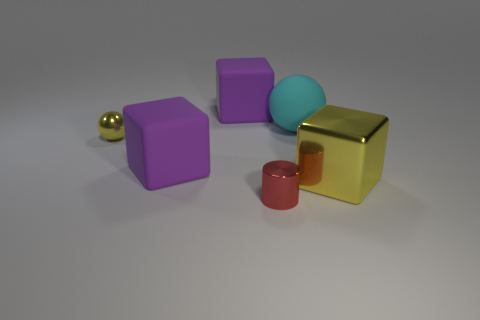How many other objects are there of the same material as the cylinder?
Your answer should be very brief. 2. Are there any big rubber blocks on the right side of the large purple rubber cube on the left side of the big matte block behind the tiny metallic ball?
Provide a succinct answer. Yes. The other small thing that is the same shape as the cyan thing is what color?
Offer a terse response. Yellow. What number of green things are metallic things or spheres?
Your response must be concise. 0. The small thing that is to the left of the rubber cube behind the cyan ball is made of what material?
Provide a short and direct response. Metal. Is the shape of the big cyan object the same as the small yellow thing?
Offer a very short reply. Yes. What is the color of the thing that is the same size as the red cylinder?
Offer a very short reply. Yellow. Are there any shiny things of the same color as the big shiny cube?
Your answer should be compact. Yes. Are any tiny blue cylinders visible?
Make the answer very short. No. Are the small thing that is in front of the yellow shiny block and the yellow block made of the same material?
Ensure brevity in your answer.  Yes. 